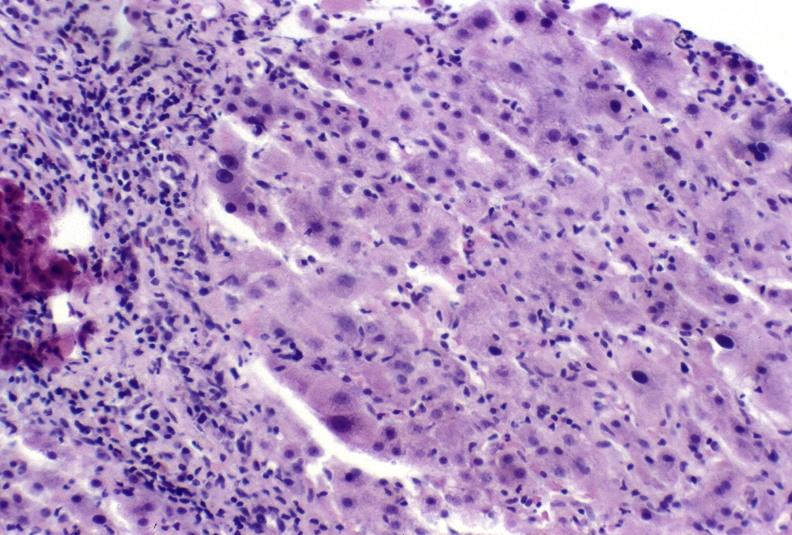what is present?
Answer the question using a single word or phrase. Hepatobiliary 